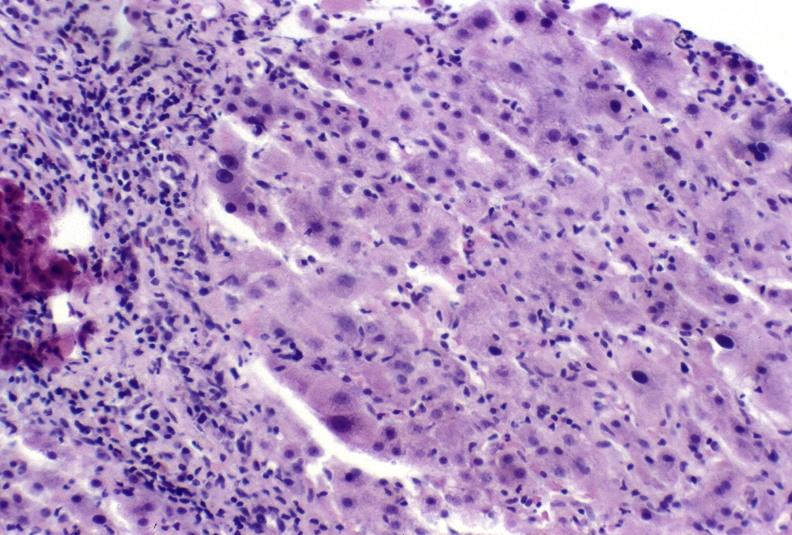what is present?
Answer the question using a single word or phrase. Hepatobiliary 